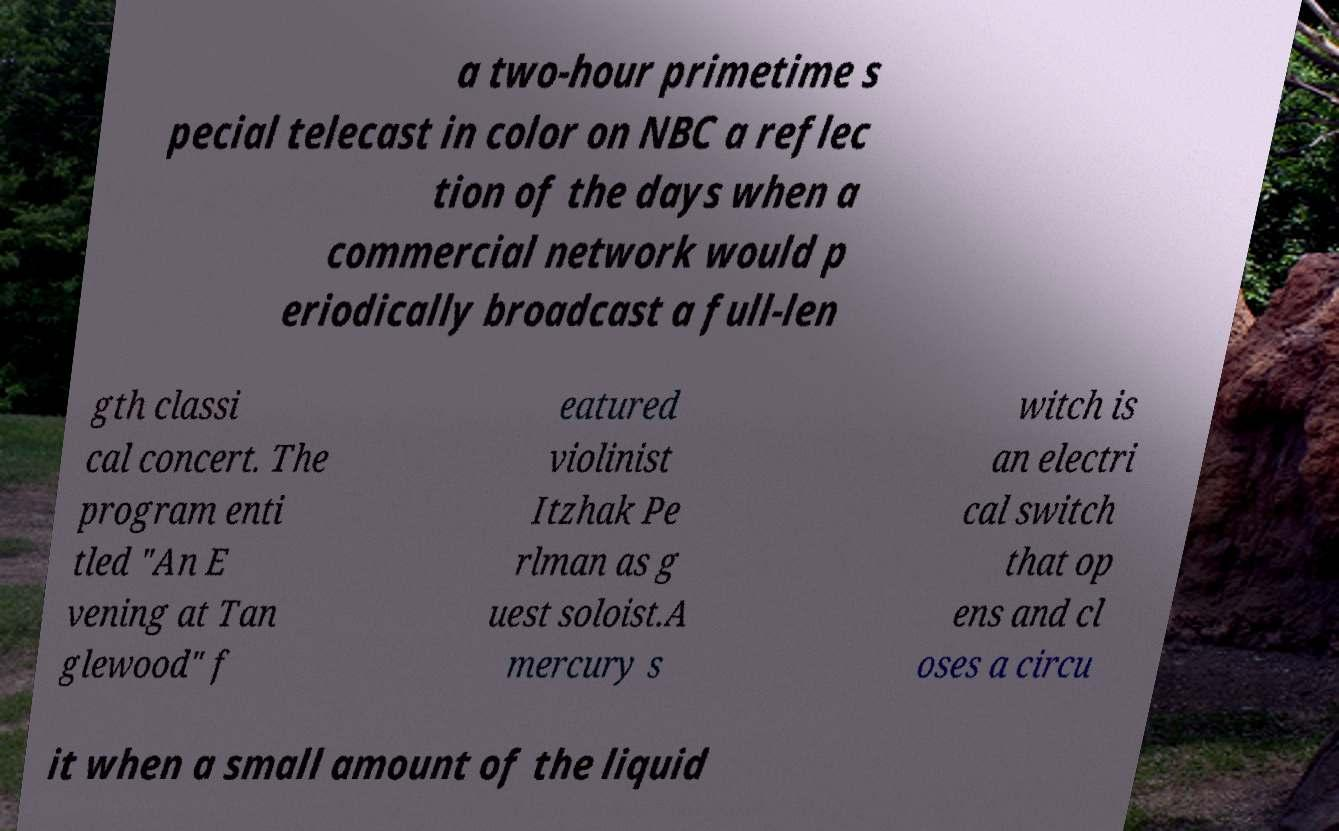Please read and relay the text visible in this image. What does it say? a two-hour primetime s pecial telecast in color on NBC a reflec tion of the days when a commercial network would p eriodically broadcast a full-len gth classi cal concert. The program enti tled "An E vening at Tan glewood" f eatured violinist Itzhak Pe rlman as g uest soloist.A mercury s witch is an electri cal switch that op ens and cl oses a circu it when a small amount of the liquid 